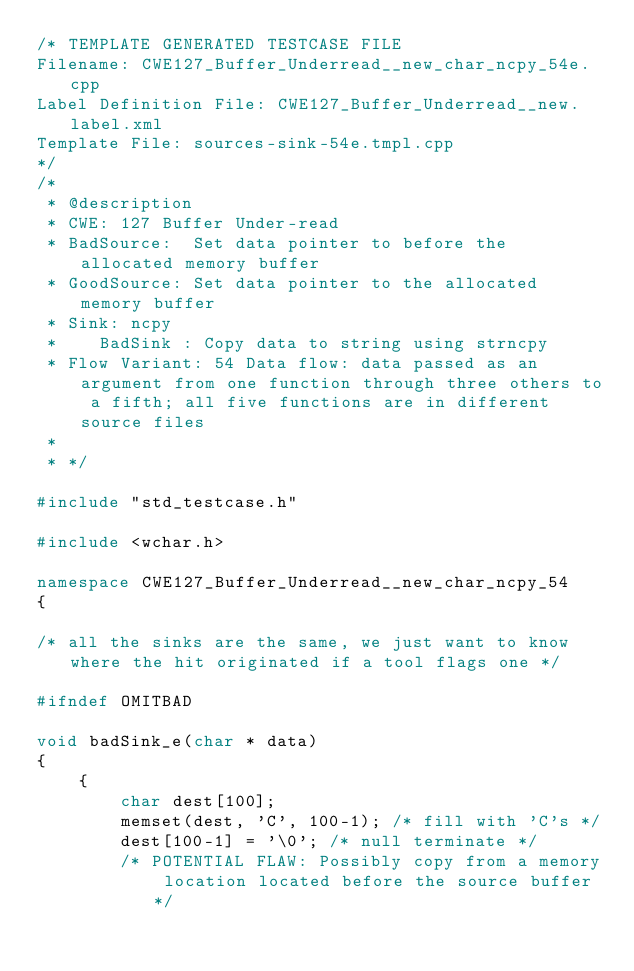<code> <loc_0><loc_0><loc_500><loc_500><_C++_>/* TEMPLATE GENERATED TESTCASE FILE
Filename: CWE127_Buffer_Underread__new_char_ncpy_54e.cpp
Label Definition File: CWE127_Buffer_Underread__new.label.xml
Template File: sources-sink-54e.tmpl.cpp
*/
/*
 * @description
 * CWE: 127 Buffer Under-read
 * BadSource:  Set data pointer to before the allocated memory buffer
 * GoodSource: Set data pointer to the allocated memory buffer
 * Sink: ncpy
 *    BadSink : Copy data to string using strncpy
 * Flow Variant: 54 Data flow: data passed as an argument from one function through three others to a fifth; all five functions are in different source files
 *
 * */

#include "std_testcase.h"

#include <wchar.h>

namespace CWE127_Buffer_Underread__new_char_ncpy_54
{

/* all the sinks are the same, we just want to know where the hit originated if a tool flags one */

#ifndef OMITBAD

void badSink_e(char * data)
{
    {
        char dest[100];
        memset(dest, 'C', 100-1); /* fill with 'C's */
        dest[100-1] = '\0'; /* null terminate */
        /* POTENTIAL FLAW: Possibly copy from a memory location located before the source buffer */</code> 